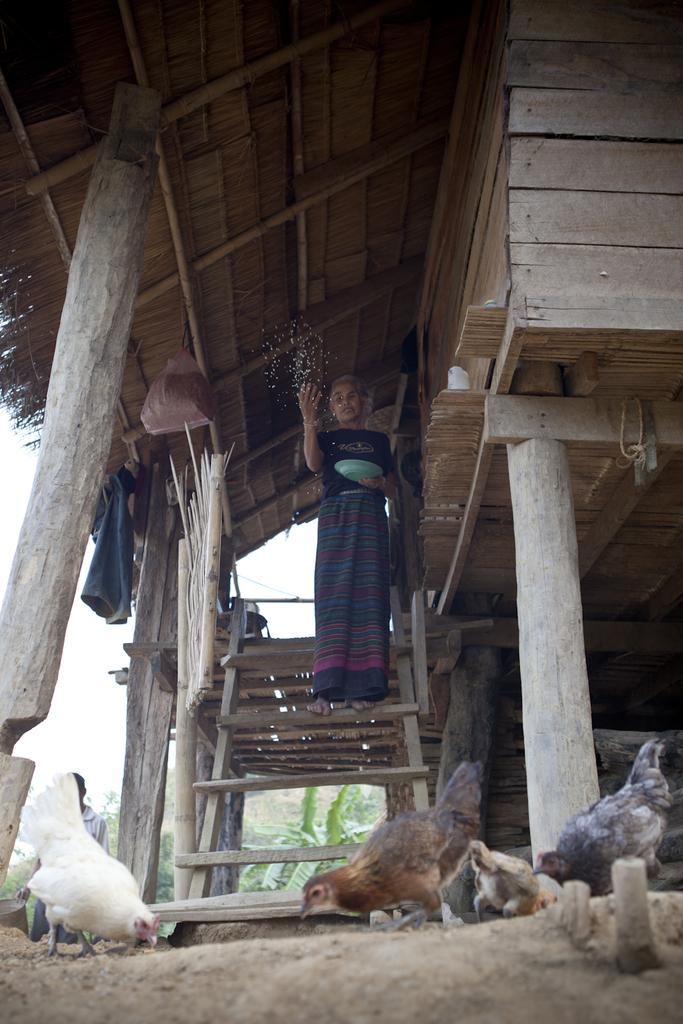What animals can be seen on the ground in the image? There are hens on the ground in the image. What type of structure is present in the image? There is a wooden house in the image. What are the people in the image doing? There are persons standing in the image, and one person is holding a serving plate in their hands. What is being used to hang clothes in the image? Clothes are hanged are hanged on sticks in the image. What type of vegetation is visible in the image? There are trees in the image. What part of the natural environment is visible in the image? The sky is visible in the image. Can you see an oven in the image? There is no oven present in the image. 